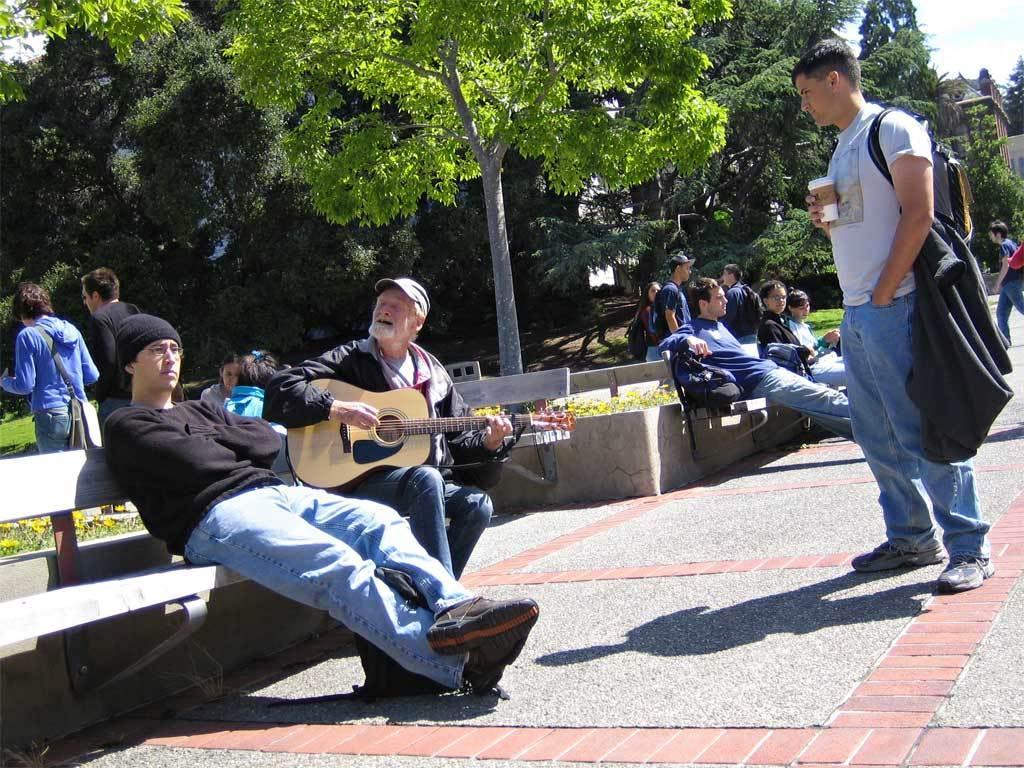Could you give a brief overview of what you see in this image? In this Image I see number of people in which few of them are sitting on benches and rest of them are standing on the path. I can also see this man is holding a guitar, In the background I see the plants and the trees. 